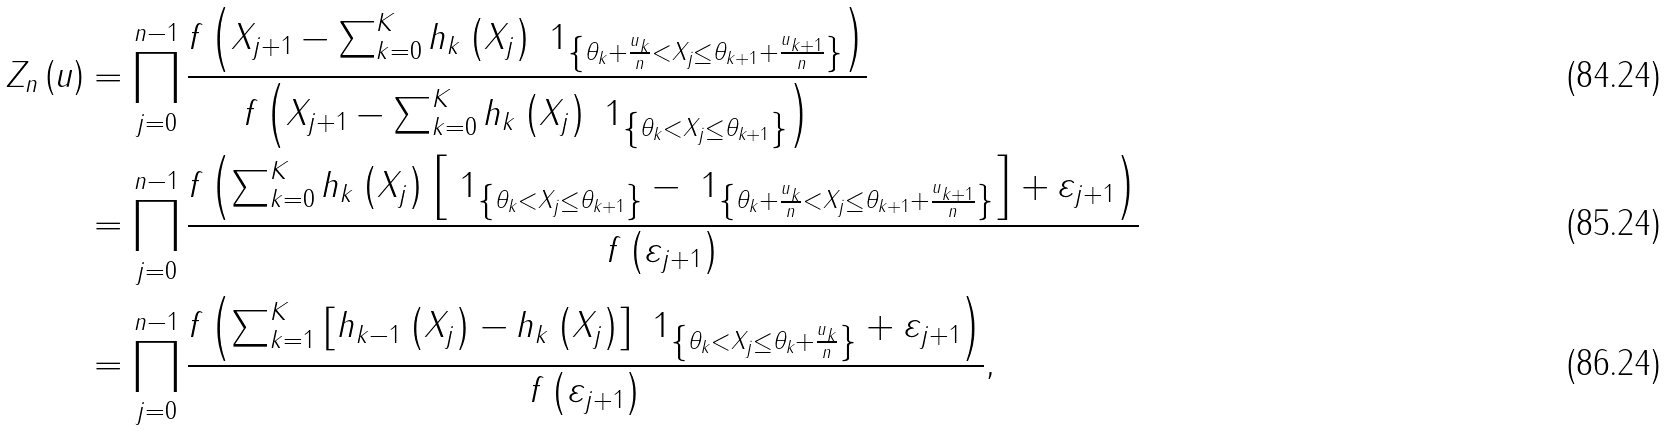Convert formula to latex. <formula><loc_0><loc_0><loc_500><loc_500>Z _ { n } \left ( { u } \right ) & = \prod _ { j = 0 } ^ { n - 1 } \frac { f \left ( X _ { j + 1 } - \sum _ { k = 0 } ^ { K } h _ { k } \left ( X _ { j } \right ) \ 1 _ { \left \{ \theta _ { k } + \frac { u _ { k } } { n } < X _ { j } \leq \theta _ { k + 1 } + \frac { u _ { k + 1 } } { n } \right \} } \right ) } { f \left ( X _ { j + 1 } - \sum _ { k = 0 } ^ { K } h _ { k } \left ( X _ { j } \right ) \ 1 _ { \left \{ \theta _ { k } < X _ { j } \leq \theta _ { k + 1 } \right \} } \right ) } \\ & = \prod _ { j = 0 } ^ { n - 1 } \frac { f \left ( \sum _ { k = 0 } ^ { K } h _ { k } \left ( X _ { j } \right ) \left [ \ 1 _ { \left \{ \theta _ { k } < X _ { j } \leq \theta _ { k + 1 } \right \} } - \ 1 _ { \left \{ \theta _ { k } + \frac { u _ { k } } { n } < X _ { j } \leq \theta _ { k + 1 } + \frac { u _ { k + 1 } } { n } \right \} } \right ] + \varepsilon _ { j + 1 } \right ) } { f \left ( \varepsilon _ { j + 1 } \right ) } \\ & = \prod _ { j = 0 } ^ { n - 1 } \frac { f \left ( \sum _ { k = 1 } ^ { K } \left [ h _ { k - 1 } \left ( X _ { j } \right ) - h _ { k } \left ( X _ { j } \right ) \right ] \ 1 _ { \left \{ \theta _ { k } < X _ { j } \leq \theta _ { k } + \frac { u _ { k } } { n } \right \} } + \varepsilon _ { j + 1 } \right ) } { f \left ( \varepsilon _ { j + 1 } \right ) } ,</formula> 